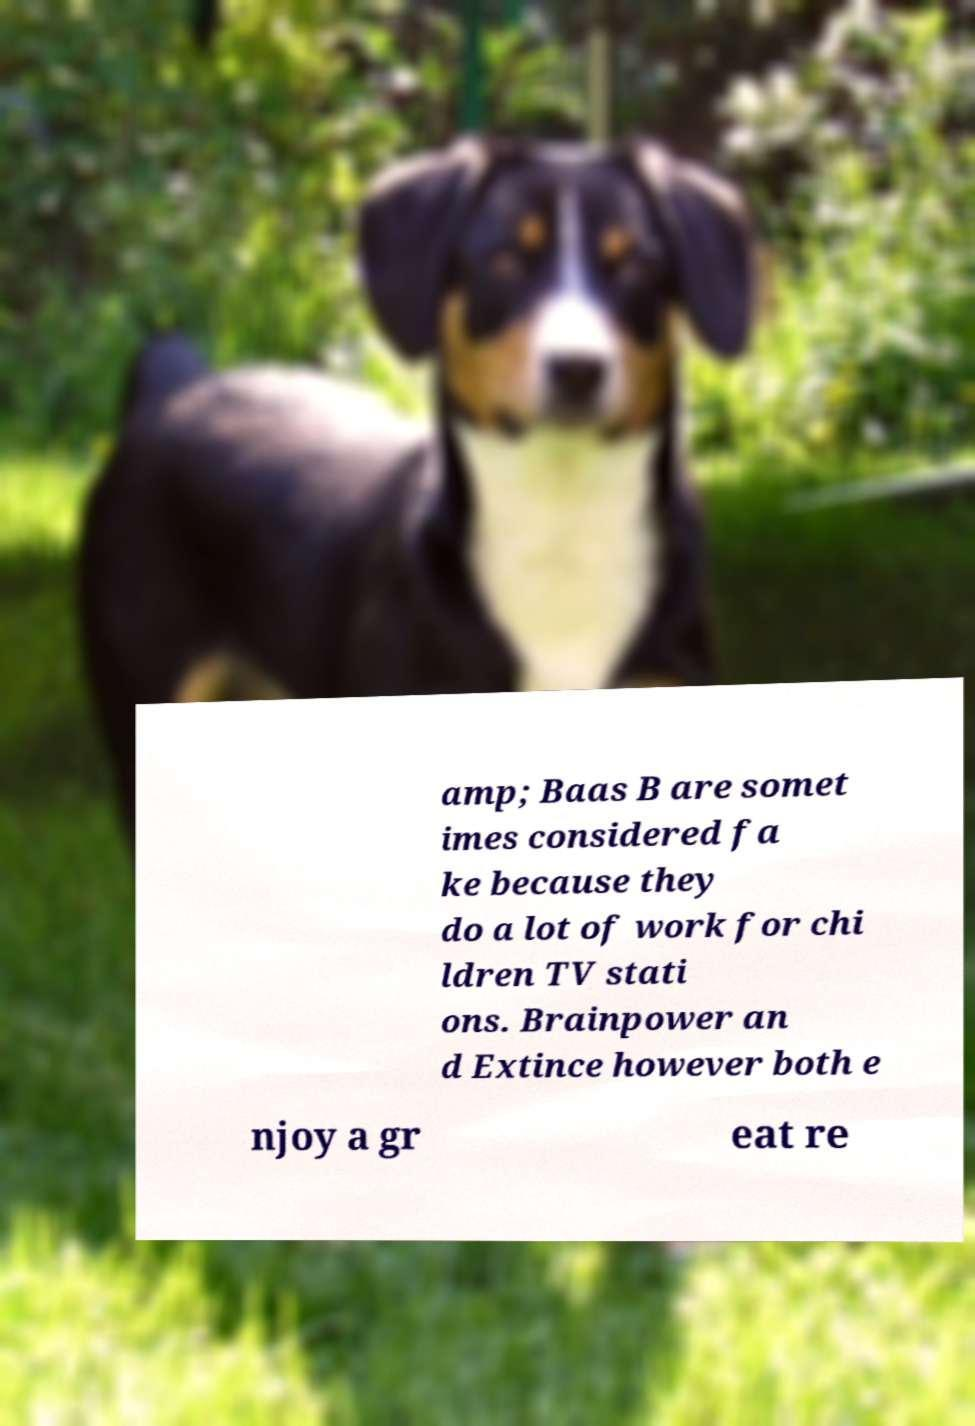Please read and relay the text visible in this image. What does it say? amp; Baas B are somet imes considered fa ke because they do a lot of work for chi ldren TV stati ons. Brainpower an d Extince however both e njoy a gr eat re 